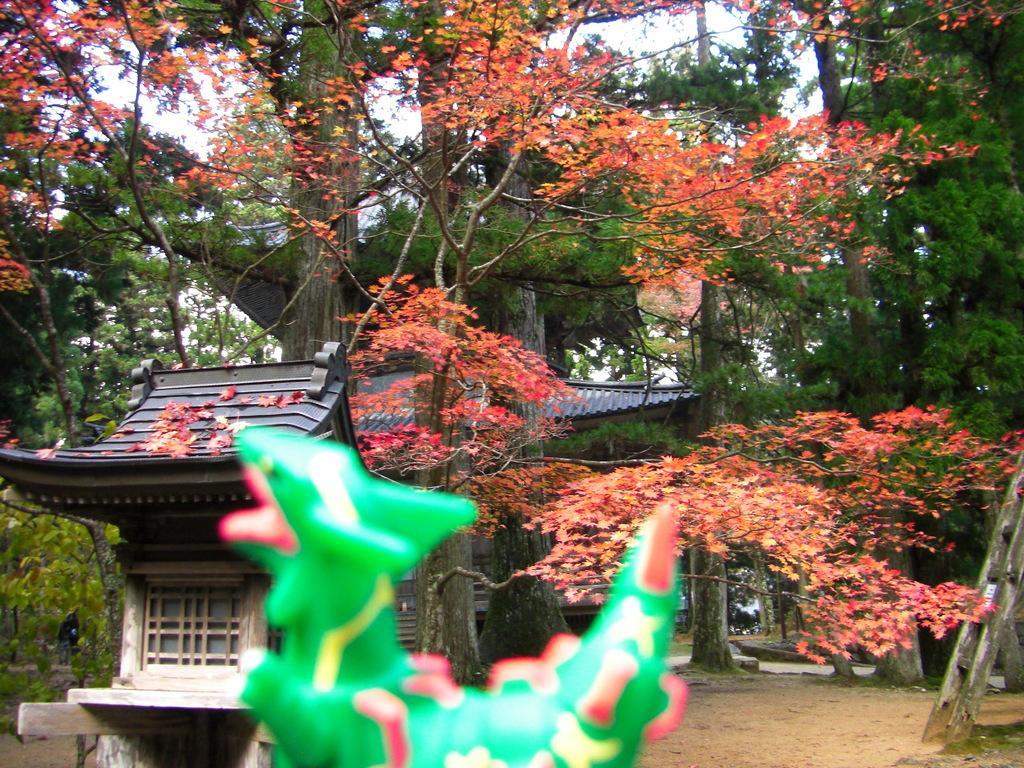How would you summarize this image in a sentence or two? At the bottom of the picture, we see the statue or a toy in green color. On the right side, we see the wooden ladder. In the middle of the picture, we see the wooden building with a grey color roof. There are trees in the background. 